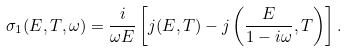<formula> <loc_0><loc_0><loc_500><loc_500>\sigma _ { 1 } ( E , T , \omega ) = \frac { i } { \omega E } \left [ j ( E , T ) - j \left ( \frac { E } { 1 - i \omega } , T \right ) \right ] .</formula> 